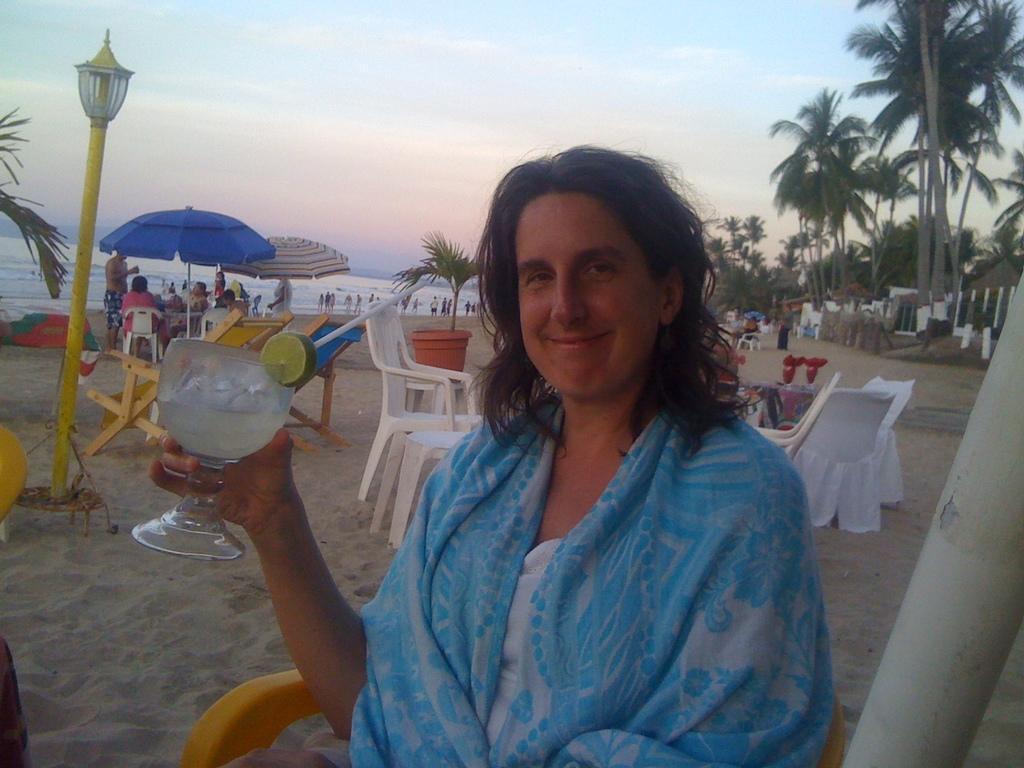Describe this image in one or two sentences. In this image we can see a person holding a glass with drink, straw, and a lemon slice. Here we can see poles, light, chairs, plants, umbrellas, trees, and people. In the background we can see water and sky. 